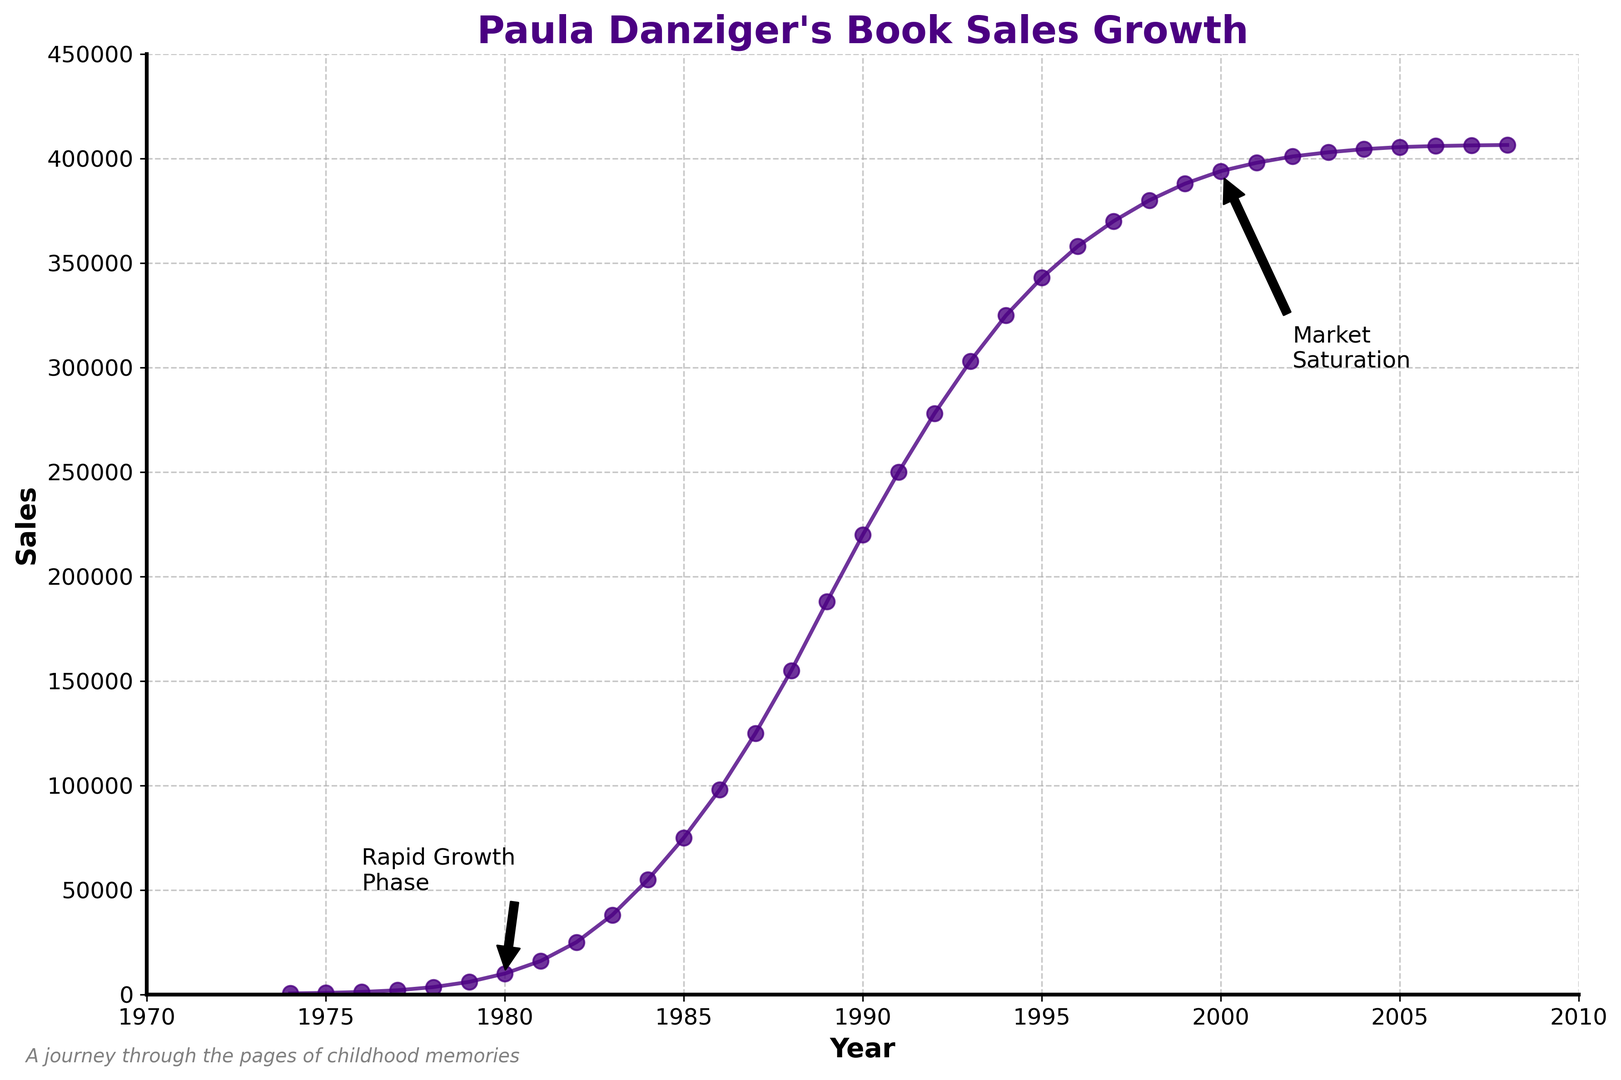What's the sales value in the year 1980? By referring to the plot, locate the data point for the year 1980 and read the corresponding sales value.
Answer: 10000 During which period did Paula Danziger's book sales experience rapid growth? Identify the annotated "Rapid Growth Phase" in the plot and read the years around the annotation. The growth starts right before 1980 and sees significant rise until 1985.
Answer: 1980 to 1985 What is the sales value difference between the years 1985 and 1987? Locate the data points for the years 1985 and 1987 from the plot. The sales values are 75000 and 125000 respectively. Subtract the former from the latter (125000 - 75000).
Answer: 50000 What is the annual sales growth from 1995 to 1996? Locate the data points for the years 1995 and 1996. The sales values are 343000 and 358000 respectively. Calculate the difference (358000 - 343000) and observe this change is for one year.
Answer: 15000 What is the maximum sales value reached according to the plotted data? Observe the highest point on the sales curve in the plot and identify the corresponding value.
Answer: 406500 Compare sales values: Which year had greater sales, 1990 or 1988? Locate data points for the years 1990 and 1988. The sales values are 220000 for 1990 and 155000 for 1988. Since 220000 > 155000, 1990 had greater sales.
Answer: 1990 In which year did the sales first exceed 100000? Identify the data point where the curve first crosses the sales mark of 100000 by moving along the curve from left to right. The year is 1987.
Answer: 1987 Estimate the sales growth trend from 2000 to 2005. Observe the plot from 2000 to 2005 where the curve is almost flat, indicating minimal growth. Read final and initial values (405500 - 394000) and notice the small difference spread over 5 years.
Answer: Minimal growth How would you describe the sales pattern after the year 2000? Observe the flatter portion of the curve after the year 2000, indicating market saturation. Note annotations and almost horizontal trend implying growth slowdown.
Answer: Market saturation How much did sales increase between 1983 and 1984? Locate data points for the years 1983 and 1984. The sales values are 38000 and 55000 respectively. Calculate the difference (55000 - 38000).
Answer: 17000 